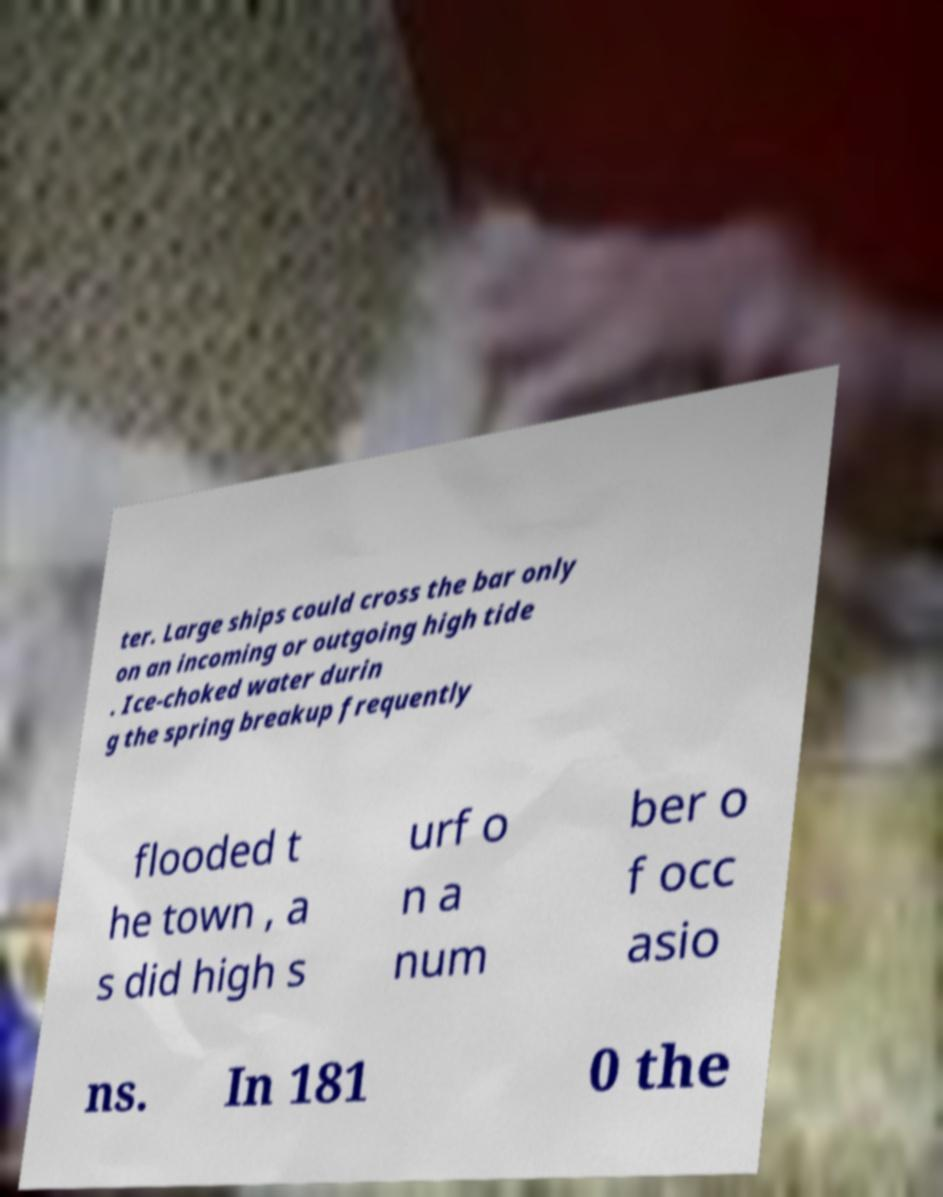Please read and relay the text visible in this image. What does it say? ter. Large ships could cross the bar only on an incoming or outgoing high tide . Ice-choked water durin g the spring breakup frequently flooded t he town , a s did high s urf o n a num ber o f occ asio ns. In 181 0 the 